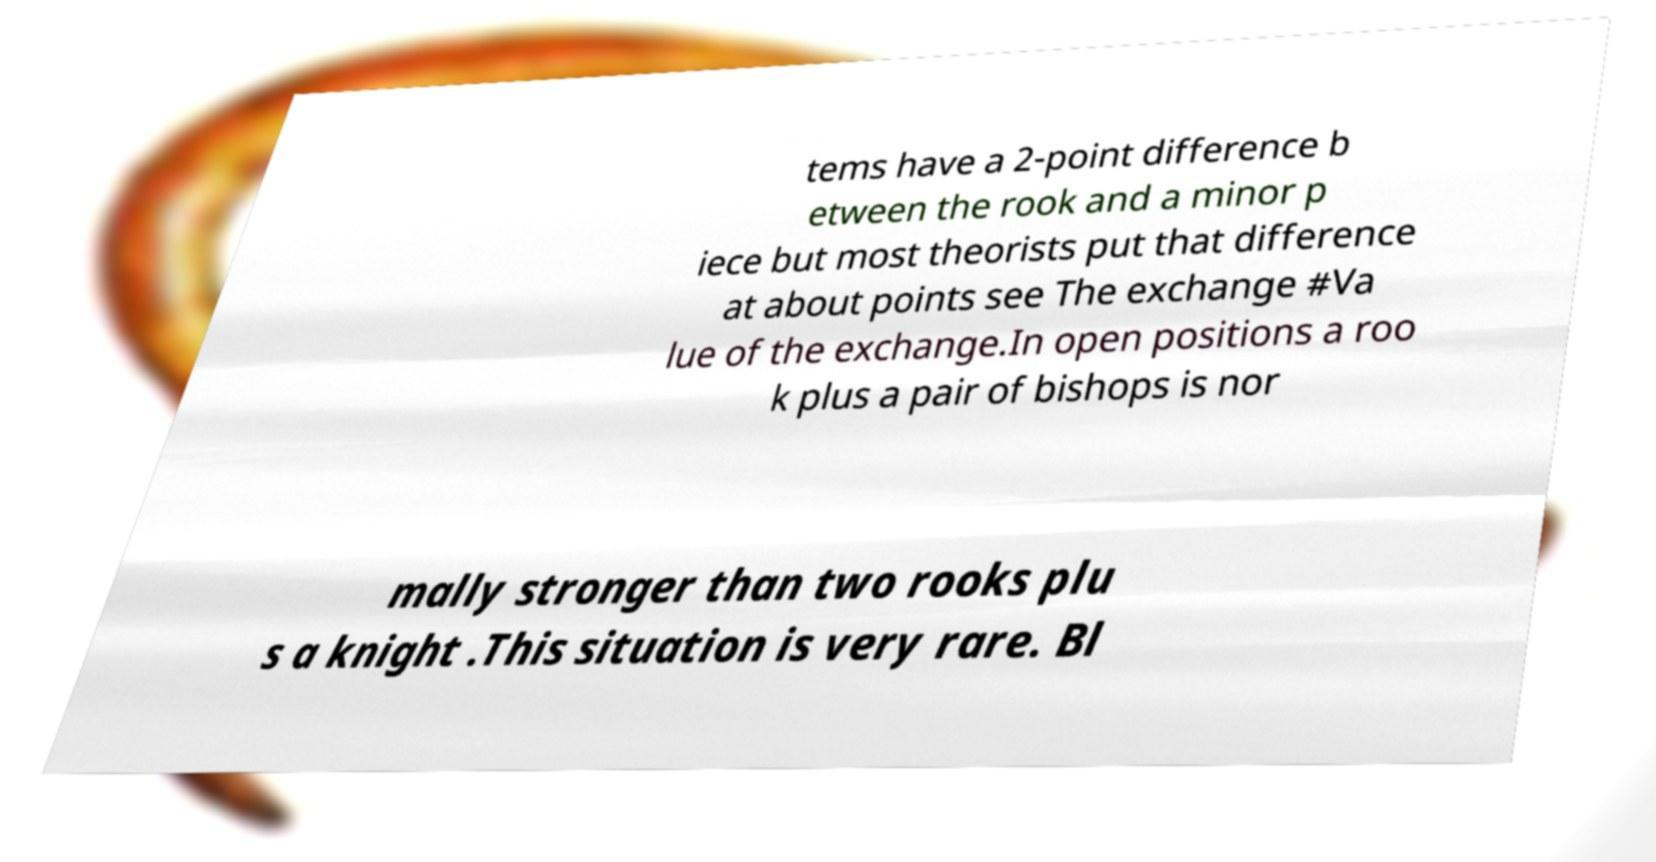Could you extract and type out the text from this image? tems have a 2-point difference b etween the rook and a minor p iece but most theorists put that difference at about points see The exchange #Va lue of the exchange.In open positions a roo k plus a pair of bishops is nor mally stronger than two rooks plu s a knight .This situation is very rare. Bl 